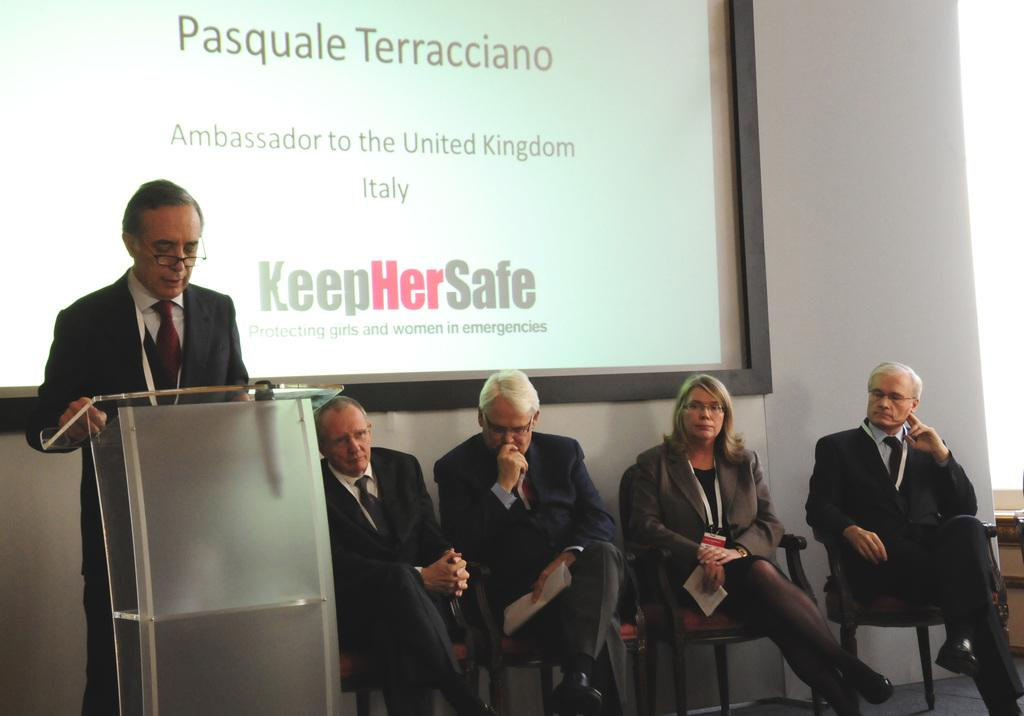What is the position of the person in the image? There is a person standing in front of the dais in the image. How many people are seated beside the standing person? There are four people sitting on chairs beside the standing person. What can be seen on the wall in the background of the image? There is a screen on the wall in the background of the image. What type of insurance policy is being discussed in the image? There is no indication of an insurance policy being discussed in the image. 